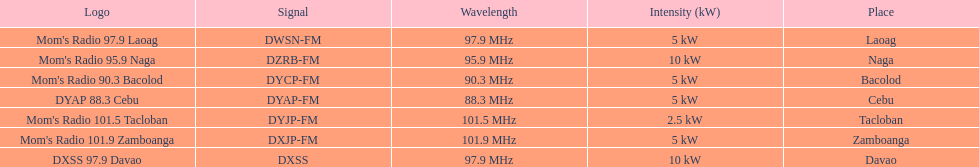How many stations broadcast with a power of 5kw? 4. 